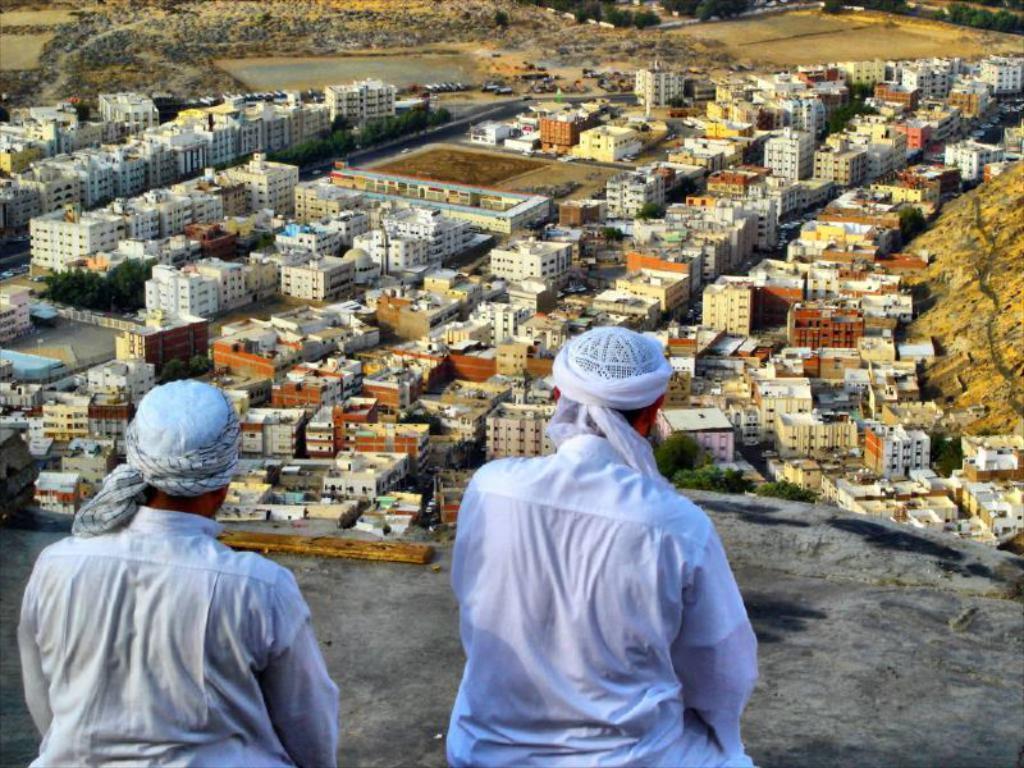Please provide a concise description of this image. In this image we can see two men on the surface. On the backside we can see a group of buildings, trees and a water body. 